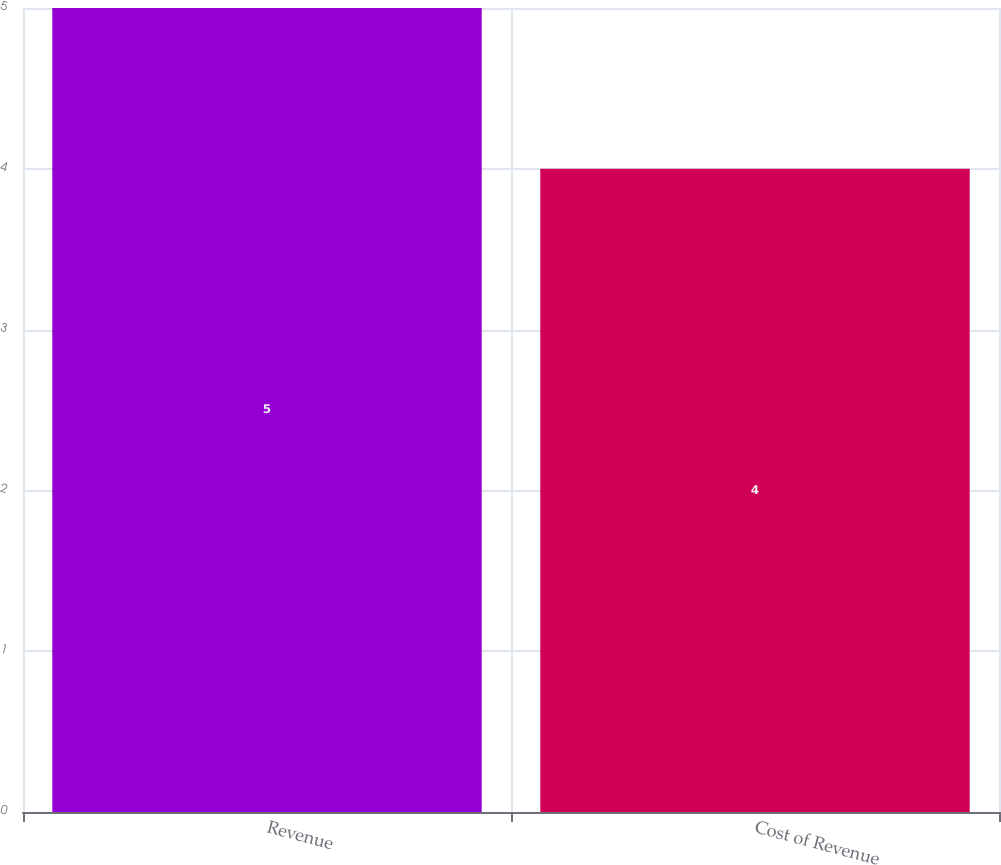Convert chart. <chart><loc_0><loc_0><loc_500><loc_500><bar_chart><fcel>Revenue<fcel>Cost of Revenue<nl><fcel>5<fcel>4<nl></chart> 